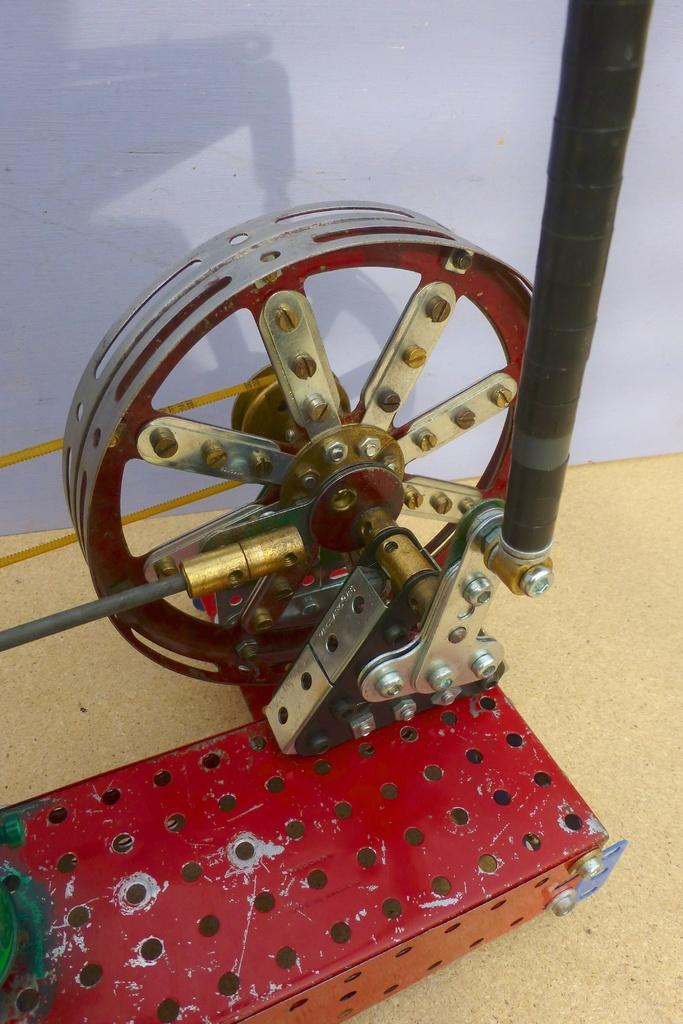What is the main subject in the foreground of the image? There is a spinning frame in the foreground of the image. What type of straw is being used by the doll in the image? There is no doll present in the image, and therefore no straw can be associated with it. 